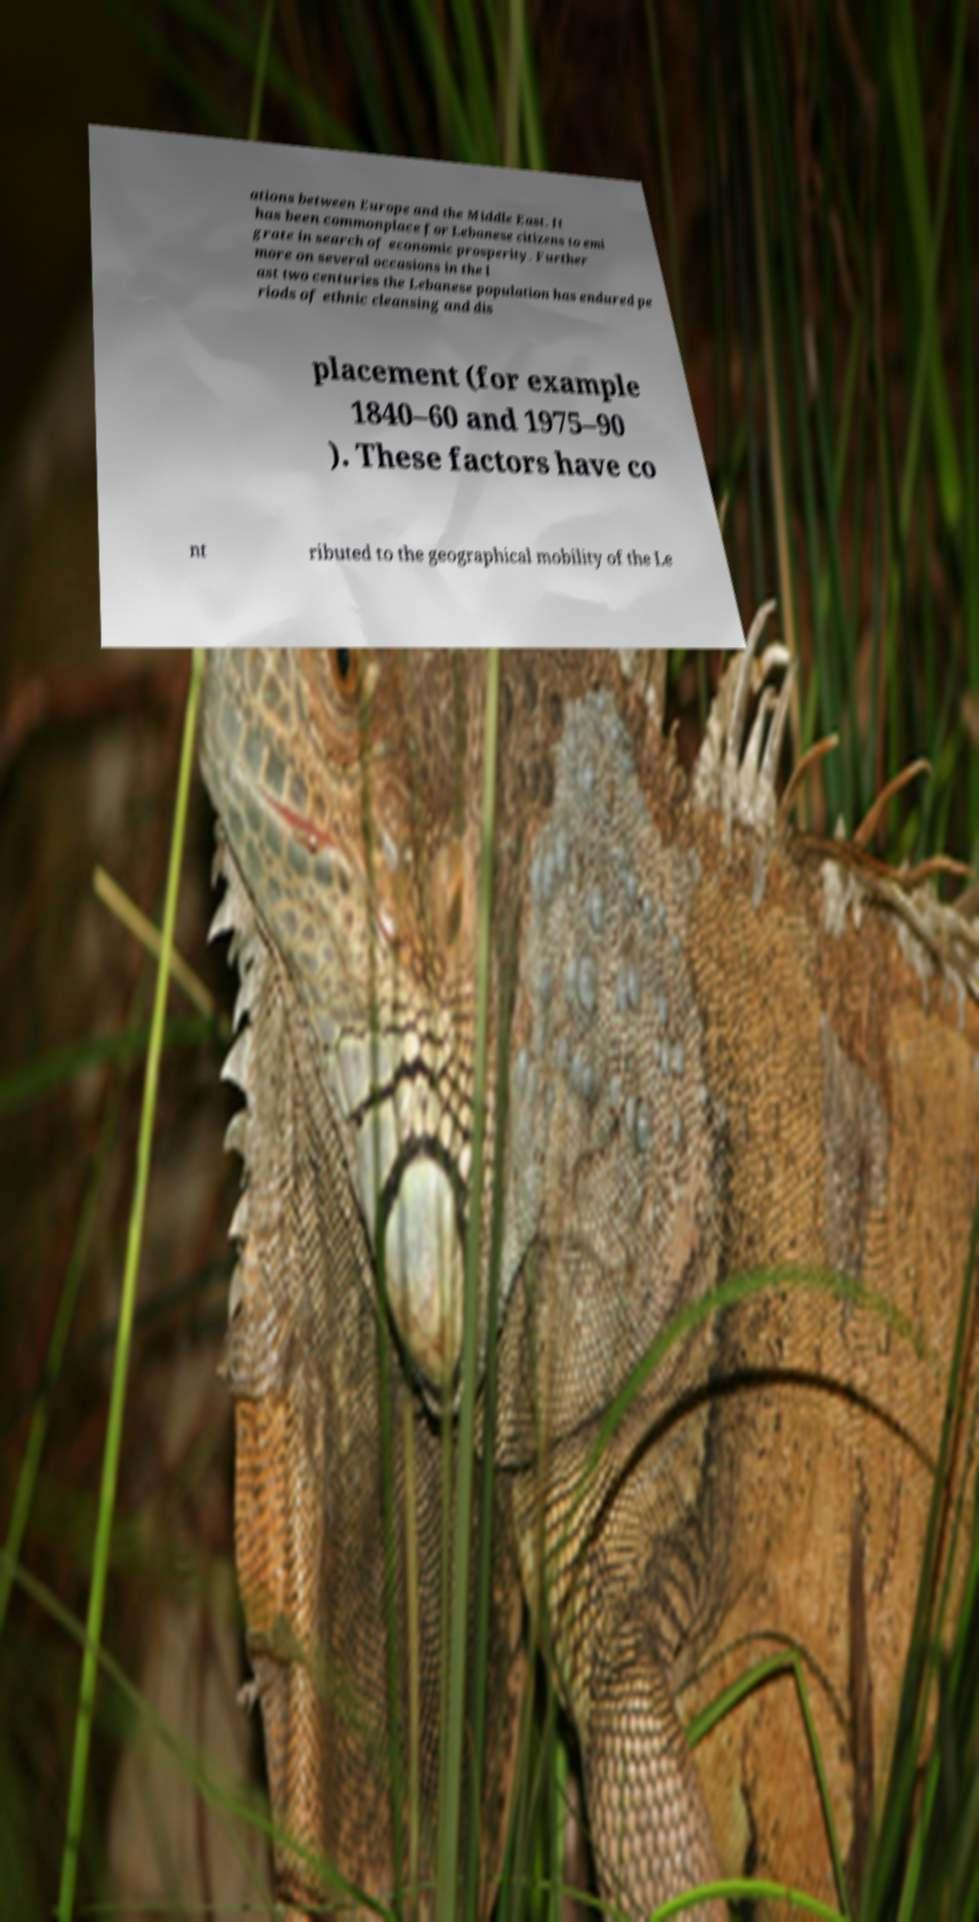I need the written content from this picture converted into text. Can you do that? ations between Europe and the Middle East. It has been commonplace for Lebanese citizens to emi grate in search of economic prosperity. Further more on several occasions in the l ast two centuries the Lebanese population has endured pe riods of ethnic cleansing and dis placement (for example 1840–60 and 1975–90 ). These factors have co nt ributed to the geographical mobility of the Le 